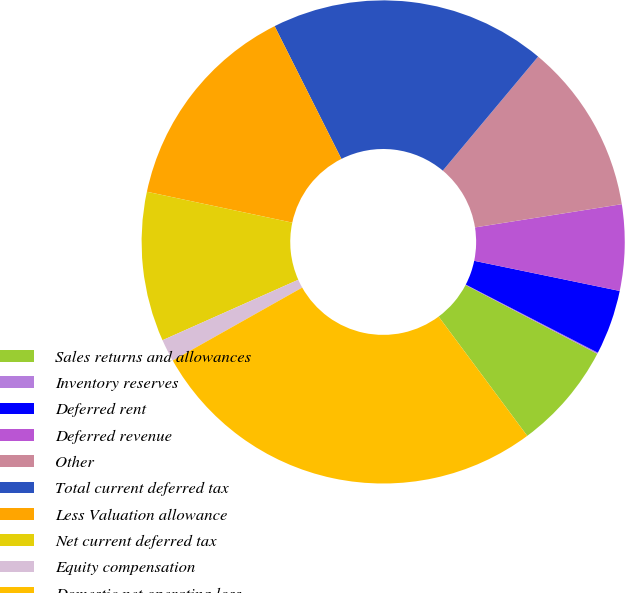Convert chart to OTSL. <chart><loc_0><loc_0><loc_500><loc_500><pie_chart><fcel>Sales returns and allowances<fcel>Inventory reserves<fcel>Deferred rent<fcel>Deferred revenue<fcel>Other<fcel>Total current deferred tax<fcel>Less Valuation allowance<fcel>Net current deferred tax<fcel>Equity compensation<fcel>Domestic net operating loss<nl><fcel>7.17%<fcel>0.08%<fcel>4.33%<fcel>5.75%<fcel>11.42%<fcel>18.5%<fcel>14.25%<fcel>10.0%<fcel>1.5%<fcel>27.0%<nl></chart> 